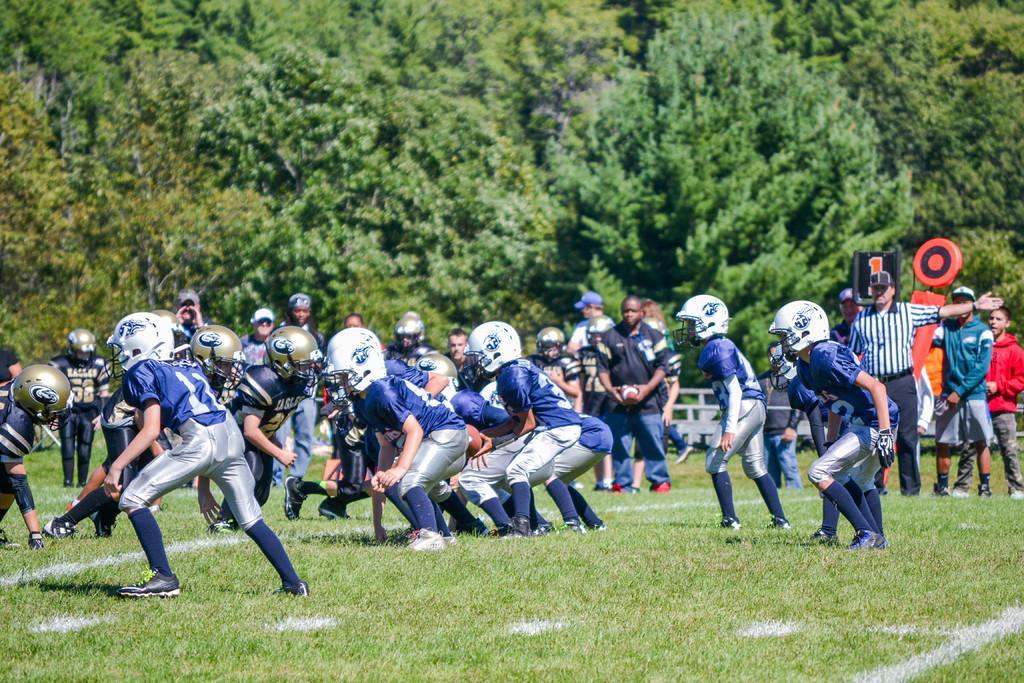Could you give a brief overview of what you see in this image? In this image there are group of people playing a game, and in the background there are some objects and trees. 